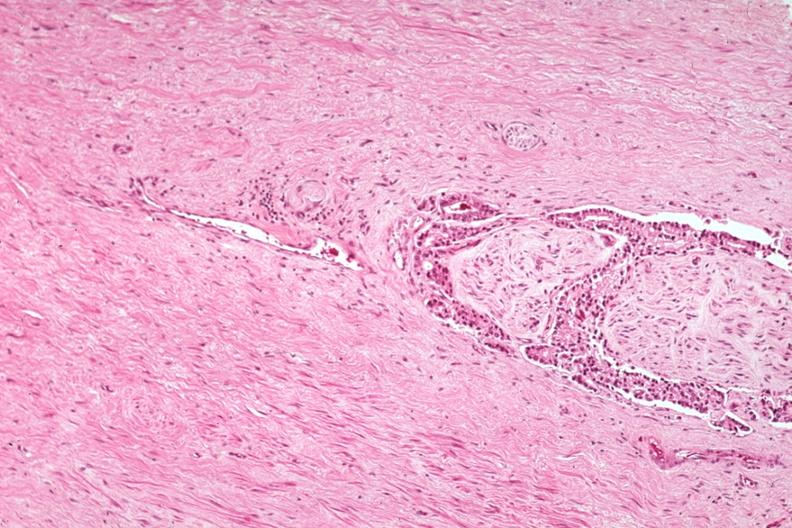what is present?
Answer the question using a single word or phrase. Prostate 